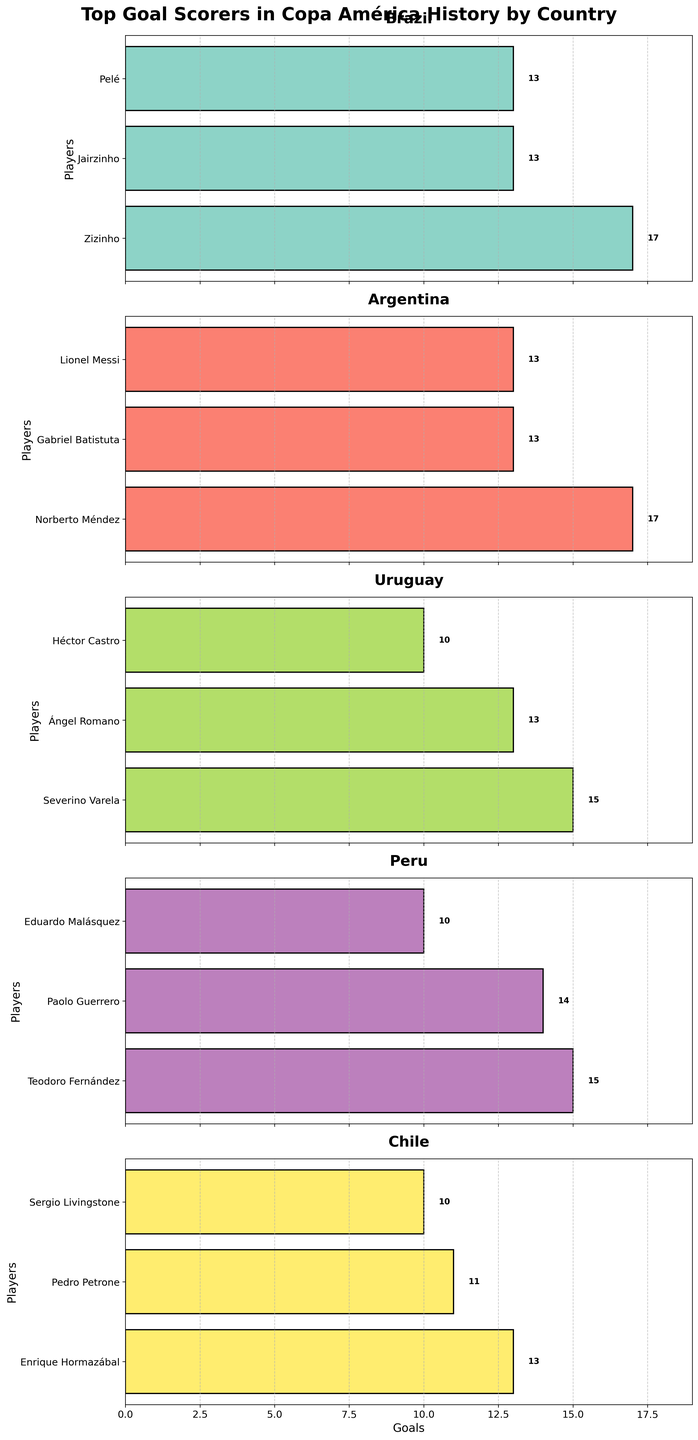Which country has the highest goal scorer in Copa América history? The title of each subplot represents a country, and the length of the bars represents goals scored. The top bar in the Argentina subplot, showing Norberto Méndez with 17 goals, is the highest among all countries.
Answer: Argentina Who are the top goal scorers for Brazil and how many goals did they score? By looking at the Brazil subplot, the players with the highest goals are Zizinho with 17 goals, Jairzinho with 13 goals, and Pelé with 13 goals.
Answer: Zizinho (17), Jairzinho (13), Pelé (13) Which player has the most goals for Uruguay, and how many goals did he score? In the Uruguay subplot, Severino Varela is at the top with 15 goals.
Answer: Severino Varela (15) How many players from Peru have scored more than 10 goals in Copa América history? Observing the Peru subplot, two players, Teodoro Fernández (15 goals) and Paolo Guerrero (14 goals), have scored more than 10 goals.
Answer: 2 Which player has scored the least number of goals among all the players mentioned, and how many goals did he score? Looking across all subplots, Eduardo Malásquez from Peru and Héctor Castro from Uruguay are at the bottom with 10 goals each.
Answer: Eduardo Malásquez and Héctor Castro (10) What is the total number of goals scored by the top goal scorers from Chile? Summing the goals from the Chile subplot: Enrique Hormazábal (13) + Pedro Petrone (11) + Sergio Livingstone (10). Thus, 13 + 11 + 10 = 34.
Answer: 34 Compare Paolo Guerrero's goals with Héctor Castro's goals. How many more goals has Paolo Guerrero scored than Héctor Castro? Paolo Guerrero has 14 goals, and Héctor Castro has 10 goals. Subtract 10 from 14 to find the difference, which is 4.
Answer: 4 What is the average number of goals scored by the top goal scorers from Argentina? Summing the goals from Argentina subplot: Norberto Méndez (17), Gabriel Batistuta (13), and Lionel Messi (13). The total is 17 + 13 + 13 = 43. The average is 43/3 = 14.33.
Answer: 14.33 Which country has the most players listed as top goal scorers? Count the players in each subplot. Brazil and Argentina both have 3 players, Uruguay has 3, Peru has 3, and Chile has 3. Each country has an equal number of players listed.
Answer: All countries have equal players 